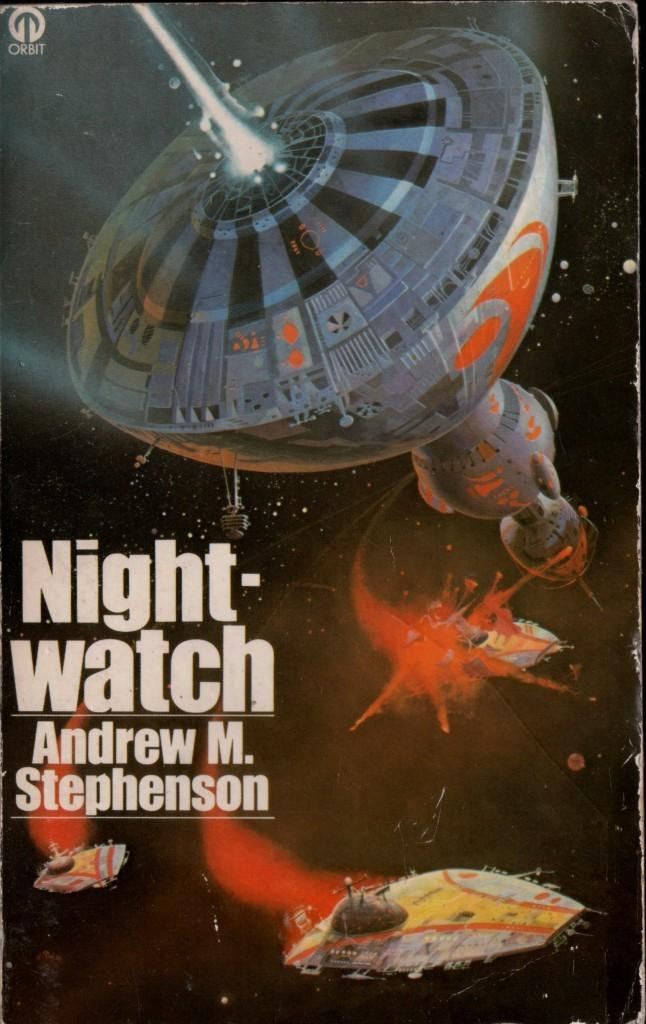<image>
Provide a brief description of the given image. A gently used copy of Night-watch by Andrew M. Stephenson 